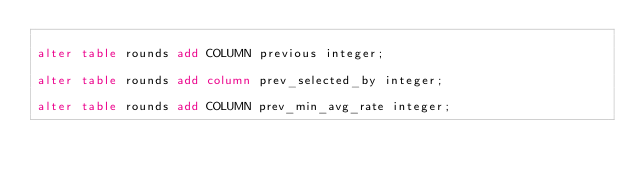Convert code to text. <code><loc_0><loc_0><loc_500><loc_500><_SQL_>
alter table rounds add COLUMN previous integer;

alter table rounds add column prev_selected_by integer;

alter table rounds add COLUMN prev_min_avg_rate integer;
</code> 